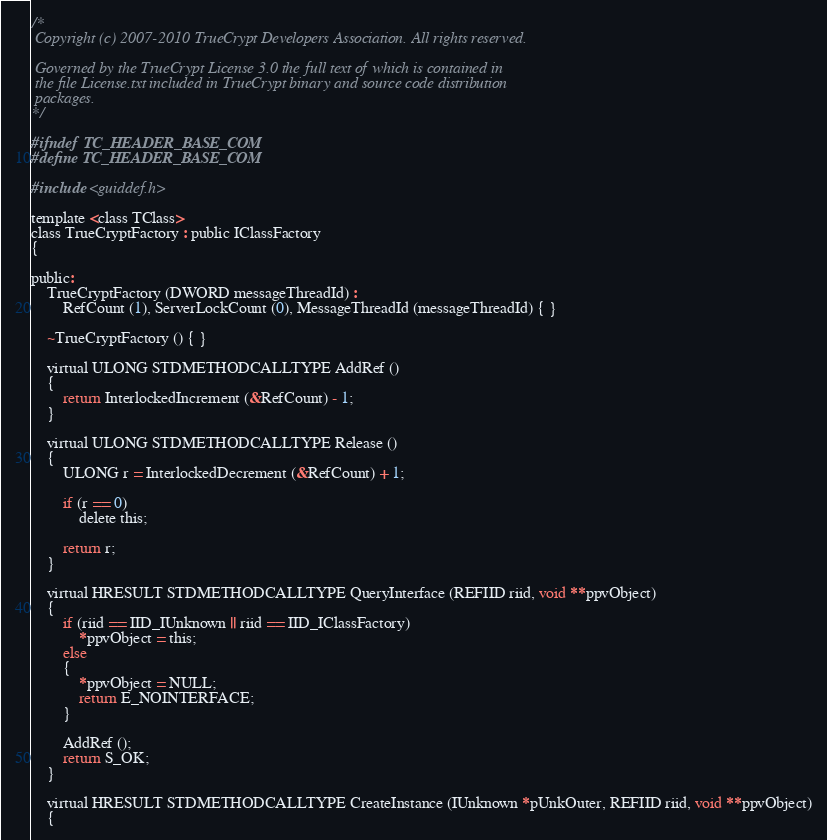<code> <loc_0><loc_0><loc_500><loc_500><_C_>/*
 Copyright (c) 2007-2010 TrueCrypt Developers Association. All rights reserved.

 Governed by the TrueCrypt License 3.0 the full text of which is contained in
 the file License.txt included in TrueCrypt binary and source code distribution
 packages.
*/

#ifndef TC_HEADER_BASE_COM
#define TC_HEADER_BASE_COM

#include <guiddef.h>

template <class TClass>
class TrueCryptFactory : public IClassFactory
{

public:
	TrueCryptFactory (DWORD messageThreadId) : 
		RefCount (1), ServerLockCount (0), MessageThreadId (messageThreadId) { }

	~TrueCryptFactory () { }
	
	virtual ULONG STDMETHODCALLTYPE AddRef ()
	{
		return InterlockedIncrement (&RefCount) - 1;
	}

	virtual ULONG STDMETHODCALLTYPE Release ()
	{
		ULONG r = InterlockedDecrement (&RefCount) + 1;

		if (r == 0)
			delete this;

		return r;
	}

	virtual HRESULT STDMETHODCALLTYPE QueryInterface (REFIID riid, void **ppvObject)
	{
		if (riid == IID_IUnknown || riid == IID_IClassFactory)
			*ppvObject = this;
		else
		{
			*ppvObject = NULL;
			return E_NOINTERFACE;
		}

		AddRef ();
		return S_OK;
	}
        
	virtual HRESULT STDMETHODCALLTYPE CreateInstance (IUnknown *pUnkOuter, REFIID riid, void **ppvObject)
	{</code> 